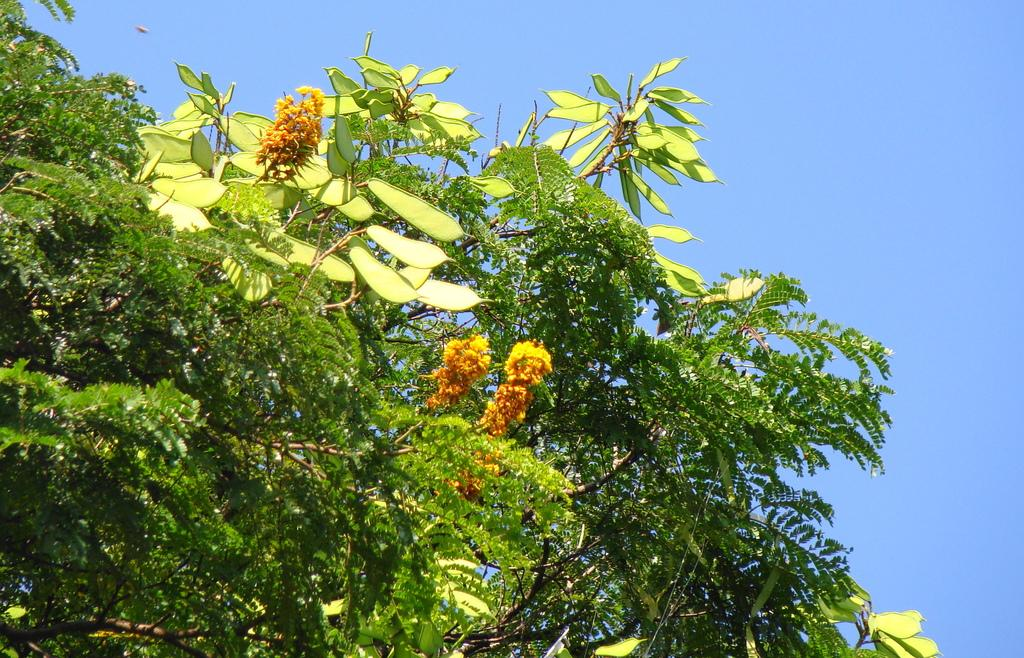What type of plant life is visible in the image? There are flowers, leaves, and branches of a tree in the image. Can you describe the specific parts of the plants that are visible? The flowers, leaves, and branches of a tree are visible in the image. What type of cart is being used to transport the expansion of the breakfast in the image? There is no cart, expansion, or breakfast present in the image; it features flowers, leaves, and branches of a tree. 